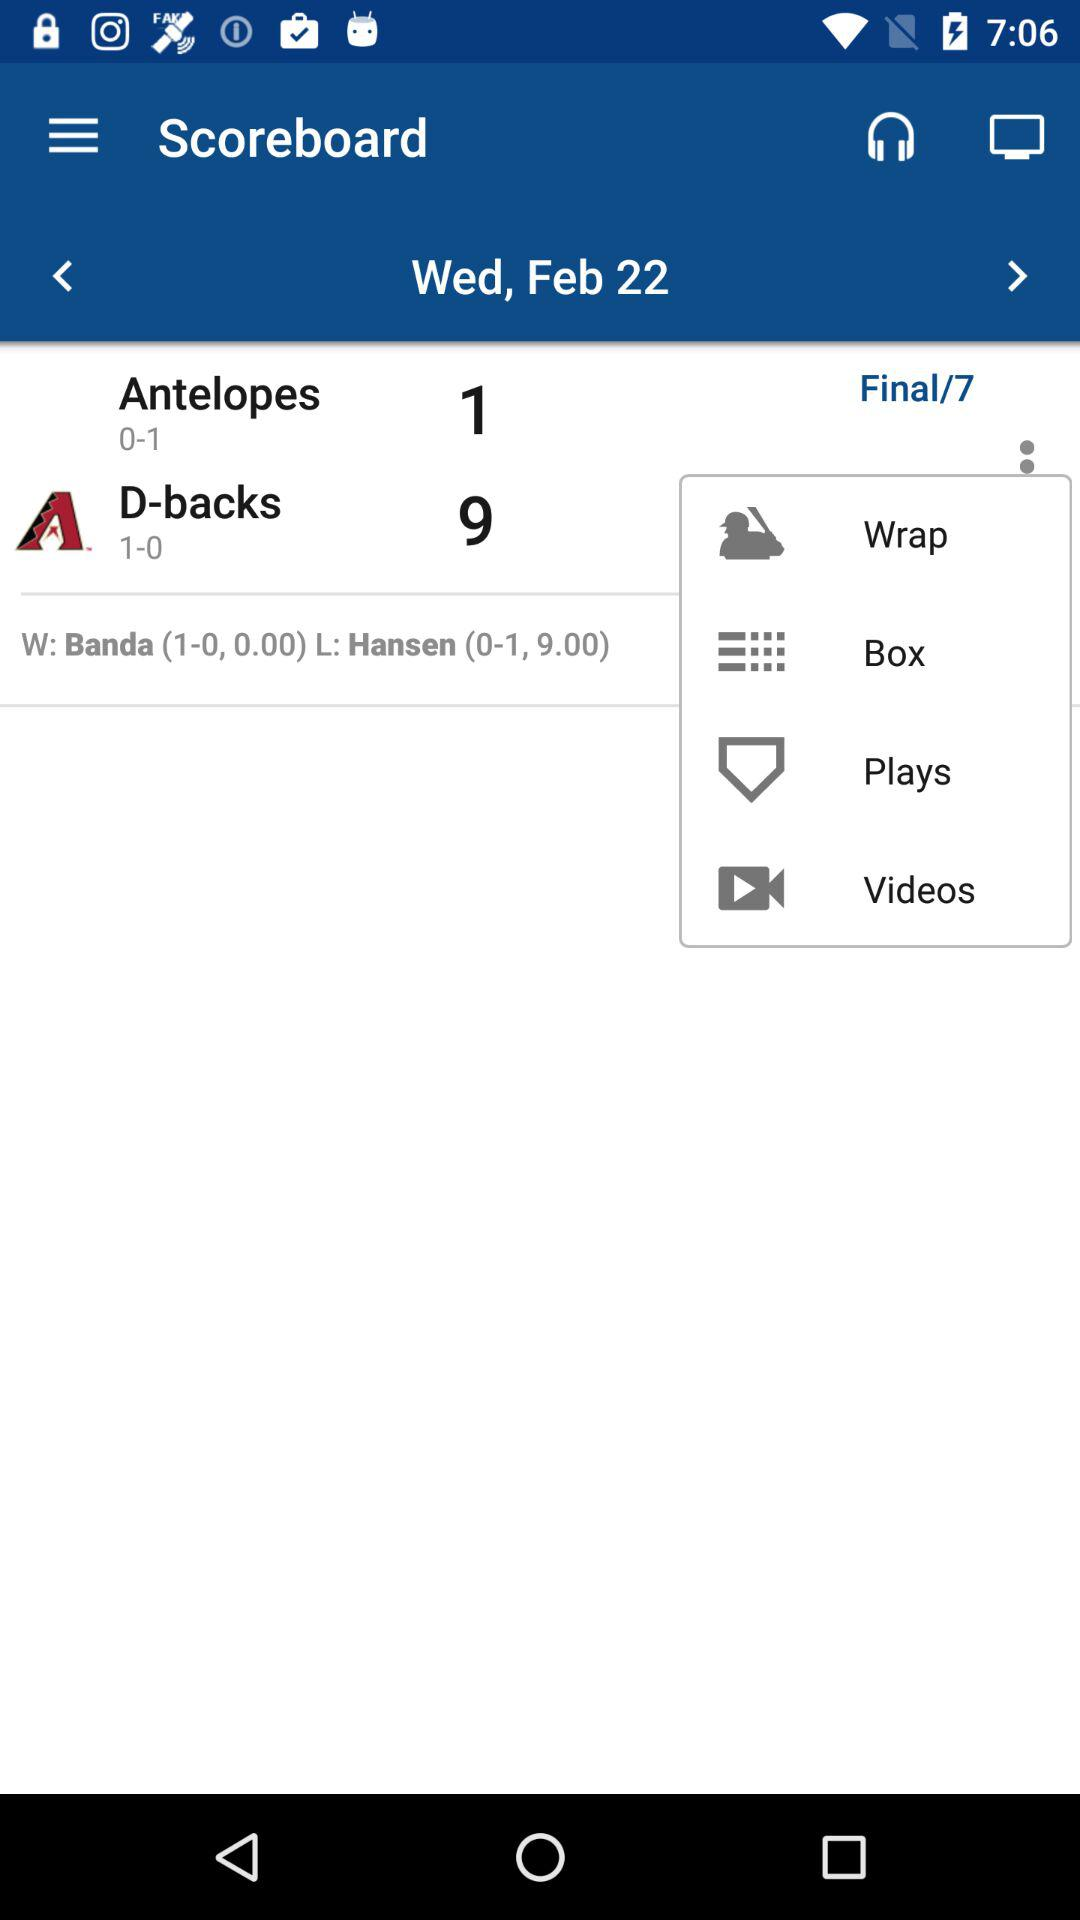What is the date? The date is Wednesday, February 22. 